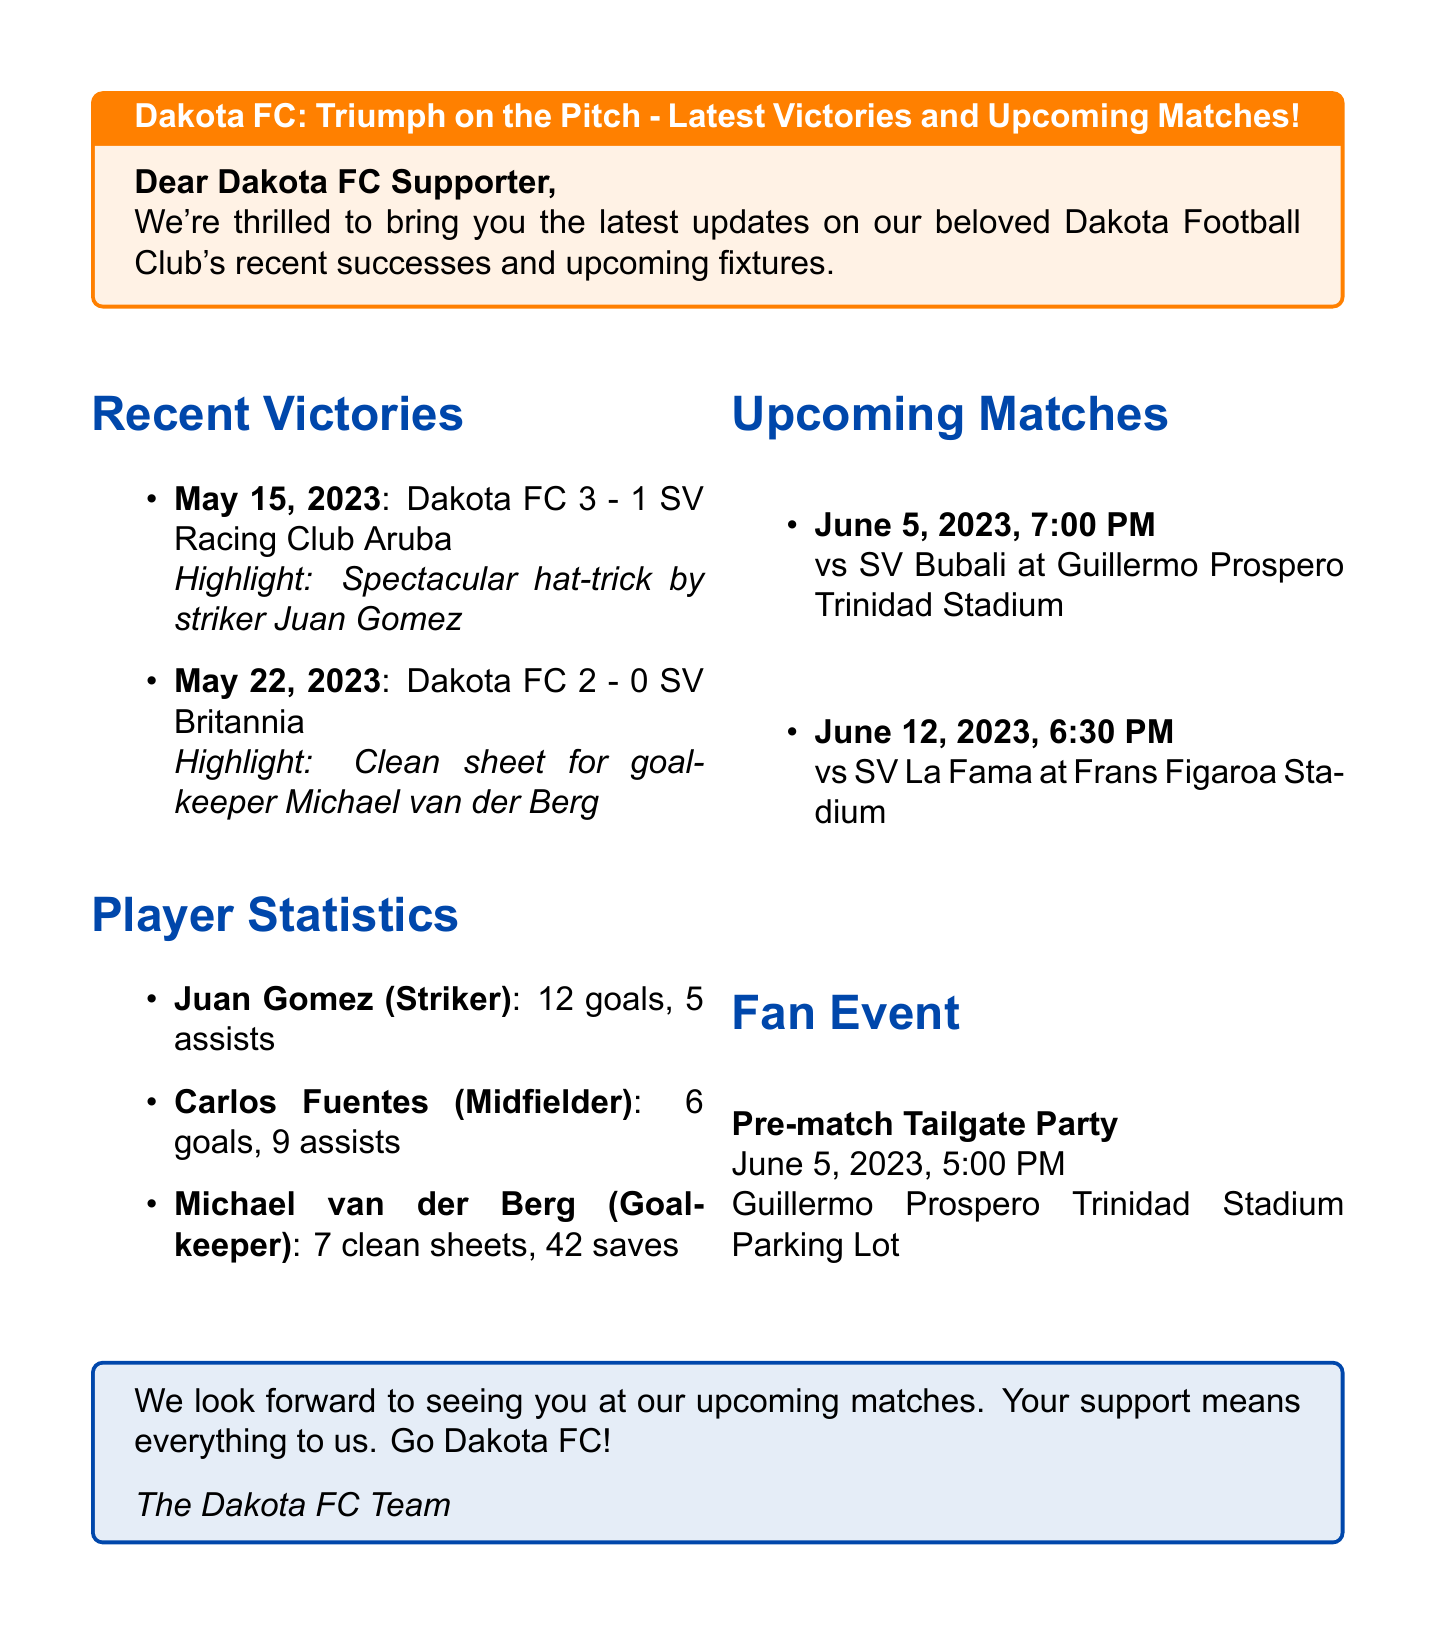What was the score for Dakota FC's match against SV Racing Club Aruba? The score for Dakota FC's match against SV Racing Club Aruba is mentioned in the recent victories section.
Answer: 3-1 Who scored a hat-trick in the match on May 15, 2023? The highlight of the match on May 15, 2023, indicates that Juan Gomez scored a hat-trick.
Answer: Juan Gomez How many goals has Juan Gomez scored this season? The player statistics indicate that Juan Gomez has scored 12 goals this season.
Answer: 12 On what date is the match against SV Bubali scheduled? The upcoming matches section provides the date for the match against SV Bubali.
Answer: June 5, 2023 What time does the Pre-match Tailgate Party start? The event details state the time for the Pre-match Tailgate Party.
Answer: 5:00 PM Which stadium will host the match against SV La Fama? The upcoming matches section specifies the venue for the match against SV La Fama.
Answer: Frans Figaroa Stadium How many clean sheets does goalkeeper Michael van der Berg have? The player statistics provide the number of clean sheets for Michael van der Berg.
Answer: 7 What is the highlight of the match against SV Britannia? The recent victories section mentions the clean sheet as the highlight of the match against SV Britannia.
Answer: Clean sheet for goalkeeper Michael van der Berg 